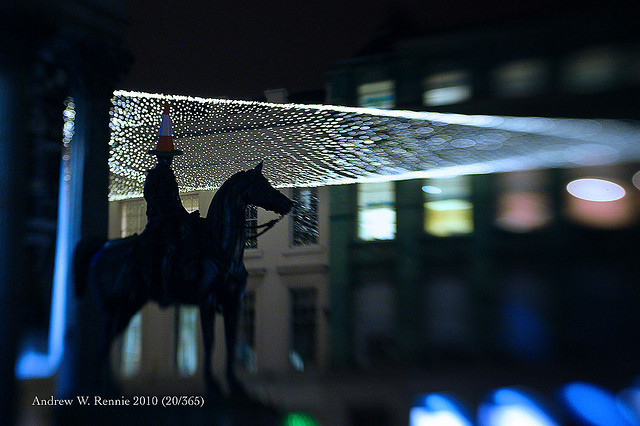Please identify all text content in this image. Andrew w. Rennie 2010 365 